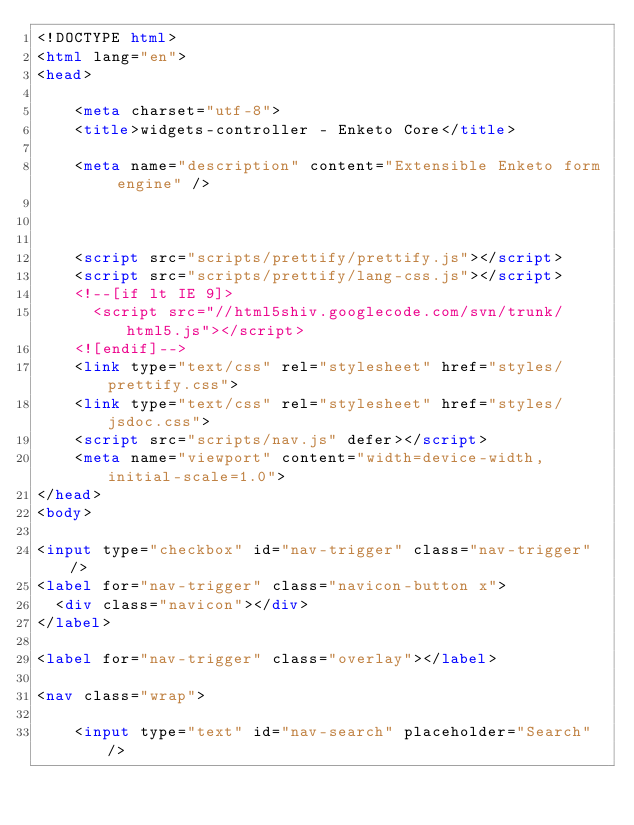Convert code to text. <code><loc_0><loc_0><loc_500><loc_500><_HTML_><!DOCTYPE html>
<html lang="en">
<head>
    
    <meta charset="utf-8">
    <title>widgets-controller - Enketo Core</title>
    
    <meta name="description" content="Extensible Enketo form engine" />
    
    
    
    <script src="scripts/prettify/prettify.js"></script>
    <script src="scripts/prettify/lang-css.js"></script>
    <!--[if lt IE 9]>
      <script src="//html5shiv.googlecode.com/svn/trunk/html5.js"></script>
    <![endif]-->
    <link type="text/css" rel="stylesheet" href="styles/prettify.css">
    <link type="text/css" rel="stylesheet" href="styles/jsdoc.css">
    <script src="scripts/nav.js" defer></script>
    <meta name="viewport" content="width=device-width, initial-scale=1.0">
</head>
<body>

<input type="checkbox" id="nav-trigger" class="nav-trigger" />
<label for="nav-trigger" class="navicon-button x">
  <div class="navicon"></div>
</label>

<label for="nav-trigger" class="overlay"></label>

<nav class="wrap">
    
    <input type="text" id="nav-search" placeholder="Search" />
    </code> 